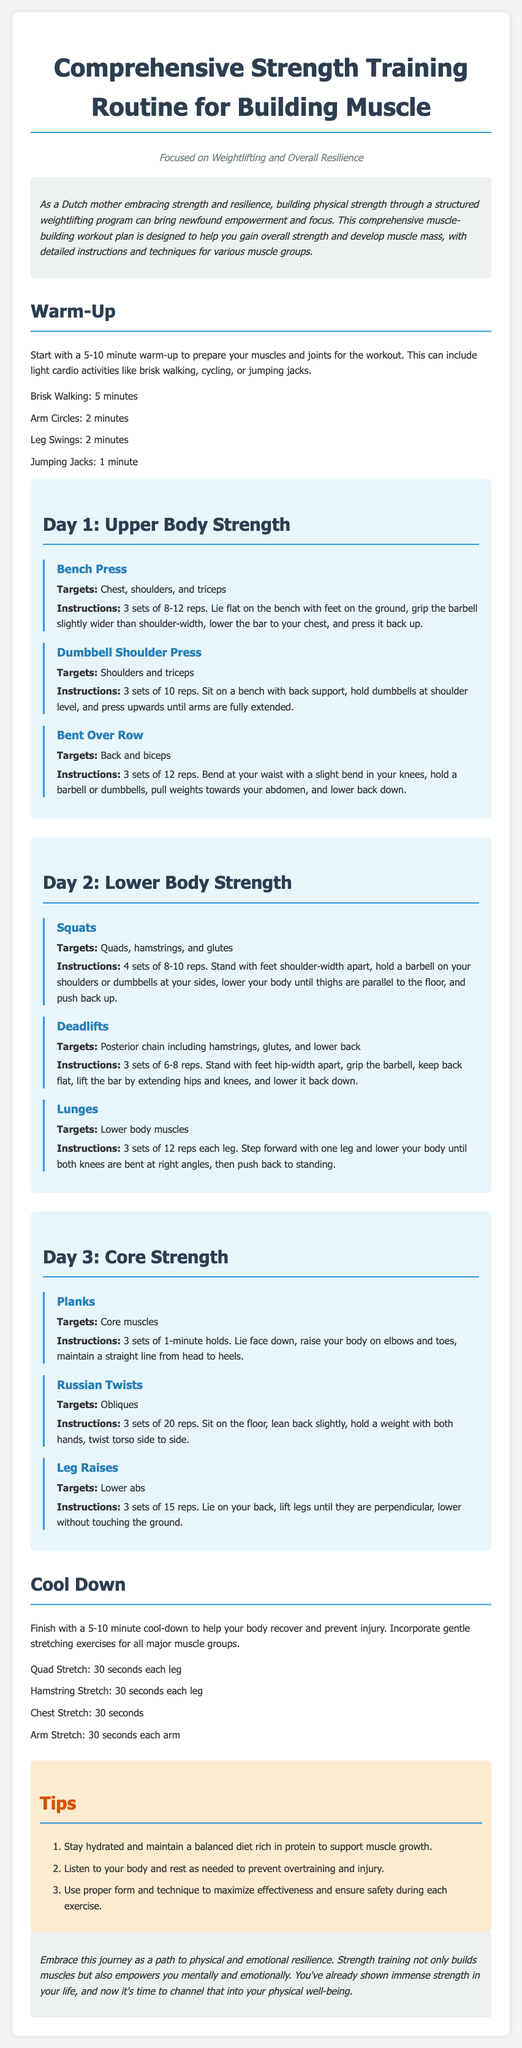What is the title of the document? The title is clearly stated at the top of the document.
Answer: Comprehensive Strength Training Routine for Building Muscle How many sets are recommended for the Bench Press exercise? The recommended sets for Bench Press are specified in the exercise section.
Answer: 3 sets What is the target muscle group for Squats? The document specifies which muscle groups are targeted by each exercise.
Answer: Quads, hamstrings, and glutes How long should the warm-up last? The warm-up duration is mentioned at the beginning of the workout section.
Answer: 5-10 minutes What exercise targets the obliques? The specific exercise targeting the obliques is listed in the Core Strength section.
Answer: Russian Twists What is the cool-down duration suggested in the document? The duration of the cool-down is indicated in the cool-down section.
Answer: 5-10 minutes How many exercises focus on Upper Body Strength in Day 1? The number of exercises is detailed in the Day 1 section.
Answer: 3 exercises What are the recommended reps for Deadlifts? The number of repetitions for Deadlifts is provided in the exercise instructions.
Answer: 6-8 reps What dietary advice is given in the Tips section? The Tips section provides guidance on nutrition to aid the exercise plan.
Answer: Maintain a balanced diet rich in protein 